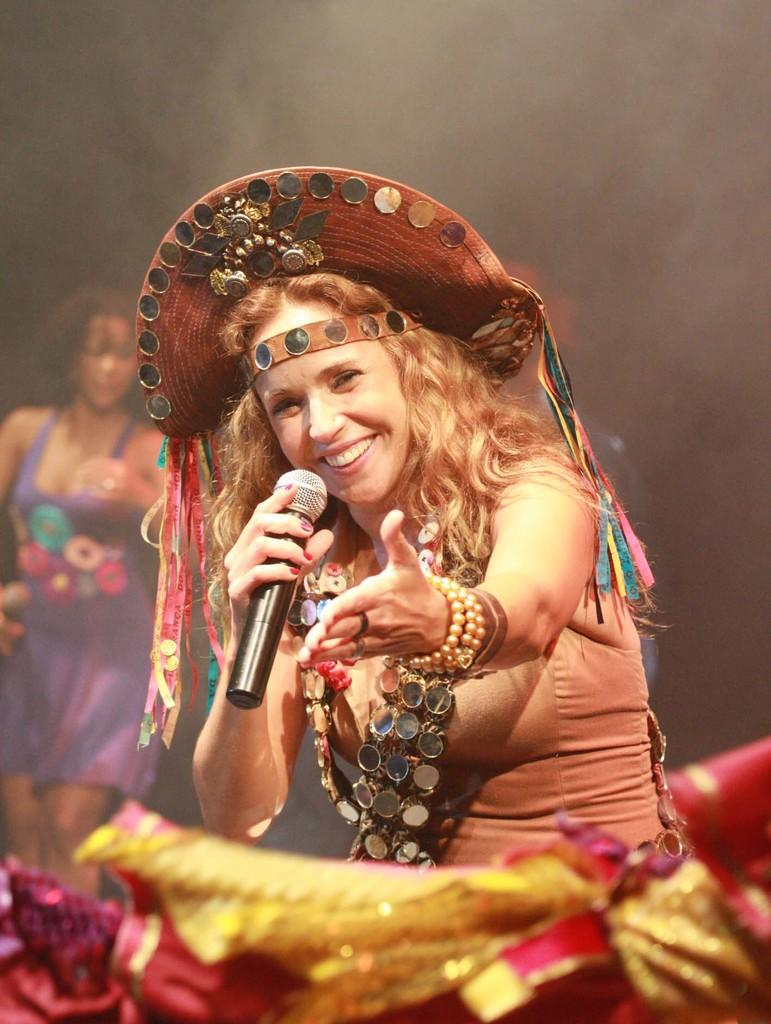What is the woman in the image holding? The woman is holding a mic. What is the woman's facial expression in the image? The woman is smiling. Can you describe the presence of another person in the image? There is another woman visible in the background of the image. What type of pies can be seen in the image? There are no pies present in the image. Can you describe the kitten playing with the engine in the image? There is no kitten or engine present in the image. 